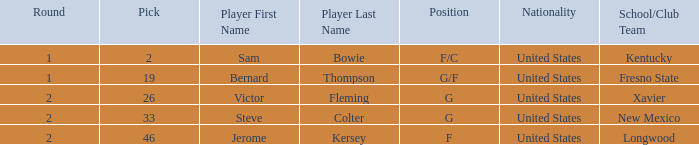What is Nationality, when Position is "G", and when Pick is greater than 26? United States. 